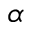Convert formula to latex. <formula><loc_0><loc_0><loc_500><loc_500>\alpha</formula> 